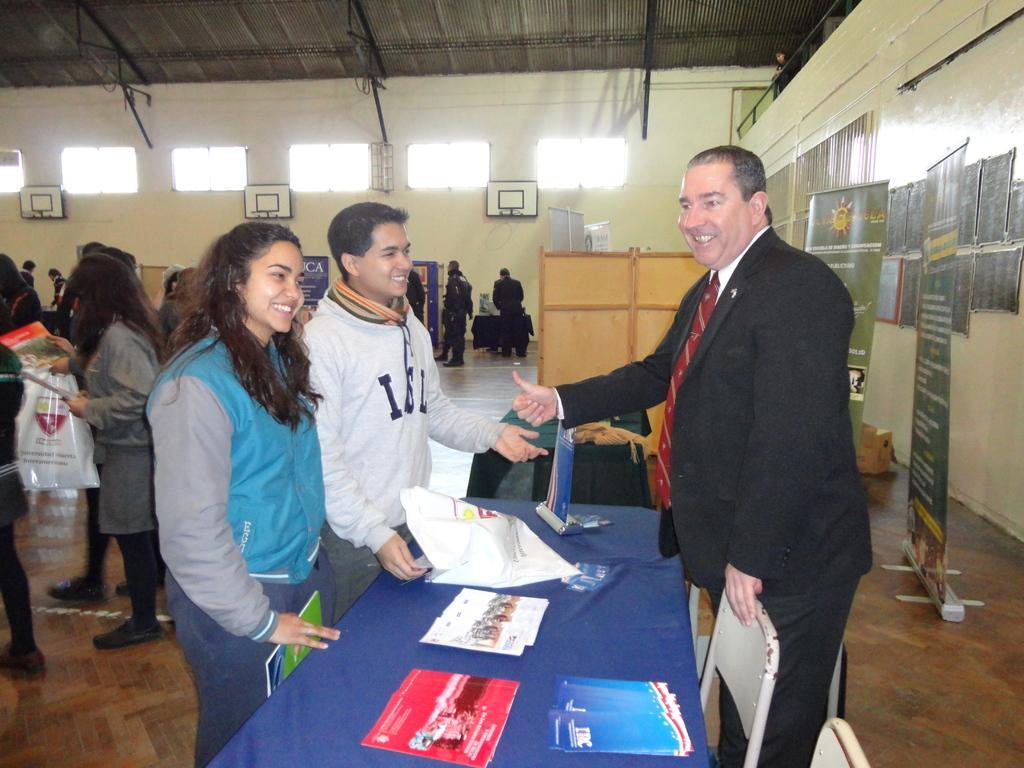In one or two sentences, can you explain what this image depicts? In the center of the image we can see persons standing at the table. On the table there is a paper and books. On the left side of the image we can see person standing on the floor. On the right side we can see advertisement and chairs. In the background there is a wooden wall, basket ball nets, windows, persons and wall. 